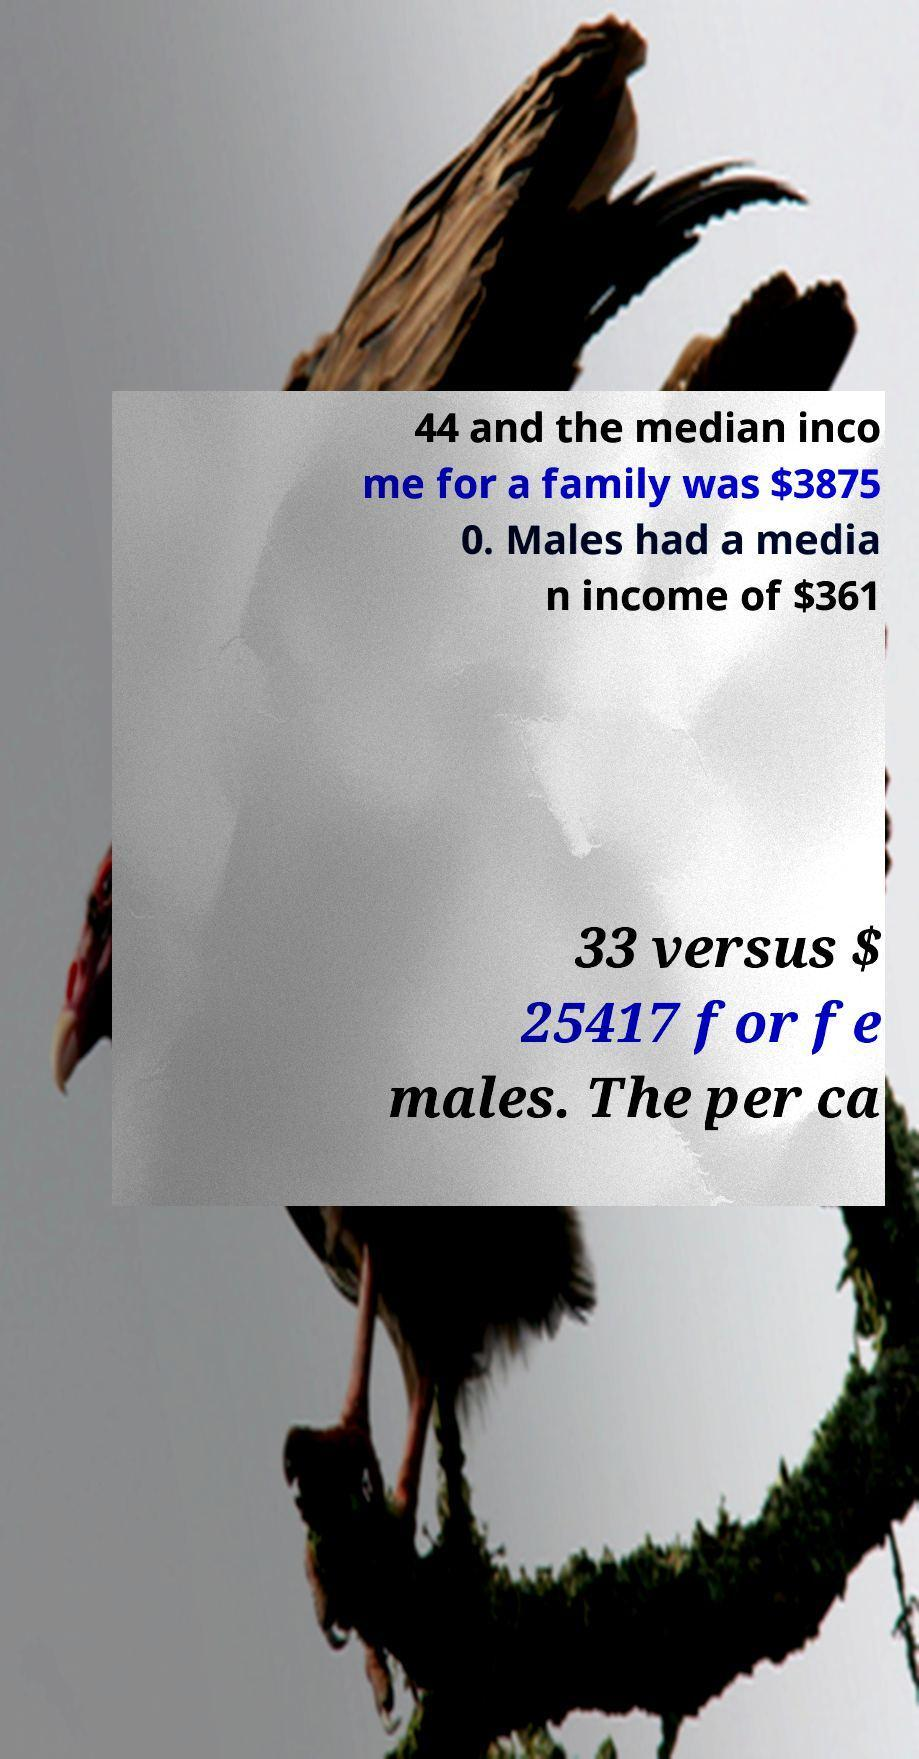Could you assist in decoding the text presented in this image and type it out clearly? 44 and the median inco me for a family was $3875 0. Males had a media n income of $361 33 versus $ 25417 for fe males. The per ca 